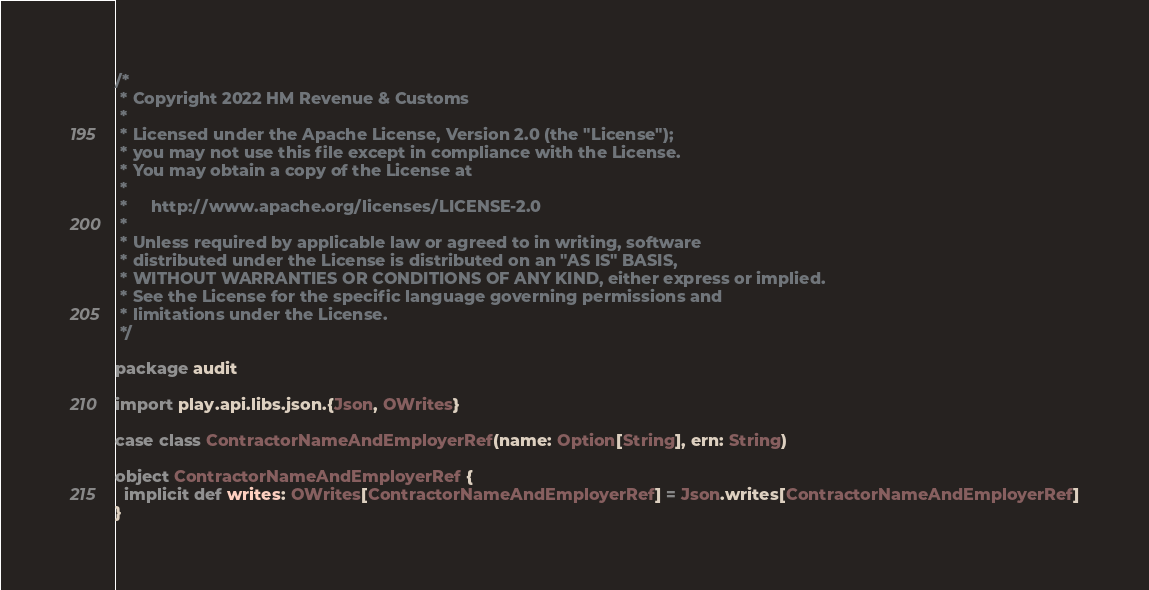Convert code to text. <code><loc_0><loc_0><loc_500><loc_500><_Scala_>/*
 * Copyright 2022 HM Revenue & Customs
 *
 * Licensed under the Apache License, Version 2.0 (the "License");
 * you may not use this file except in compliance with the License.
 * You may obtain a copy of the License at
 *
 *     http://www.apache.org/licenses/LICENSE-2.0
 *
 * Unless required by applicable law or agreed to in writing, software
 * distributed under the License is distributed on an "AS IS" BASIS,
 * WITHOUT WARRANTIES OR CONDITIONS OF ANY KIND, either express or implied.
 * See the License for the specific language governing permissions and
 * limitations under the License.
 */

package audit

import play.api.libs.json.{Json, OWrites}

case class ContractorNameAndEmployerRef(name: Option[String], ern: String)

object ContractorNameAndEmployerRef {
  implicit def writes: OWrites[ContractorNameAndEmployerRef] = Json.writes[ContractorNameAndEmployerRef]
}
</code> 